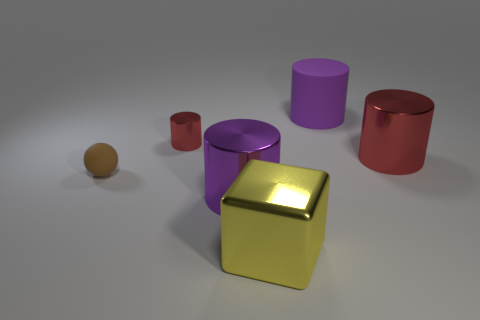Subtract all purple metal cylinders. How many cylinders are left? 3 Add 3 yellow metallic cylinders. How many objects exist? 9 Subtract all cylinders. How many objects are left? 2 Subtract all red cylinders. How many cyan cubes are left? 0 Add 5 tiny brown balls. How many tiny brown balls exist? 6 Subtract all purple cylinders. How many cylinders are left? 2 Subtract 1 brown spheres. How many objects are left? 5 Subtract 2 cylinders. How many cylinders are left? 2 Subtract all purple balls. Subtract all gray cylinders. How many balls are left? 1 Subtract all blue matte cubes. Subtract all yellow cubes. How many objects are left? 5 